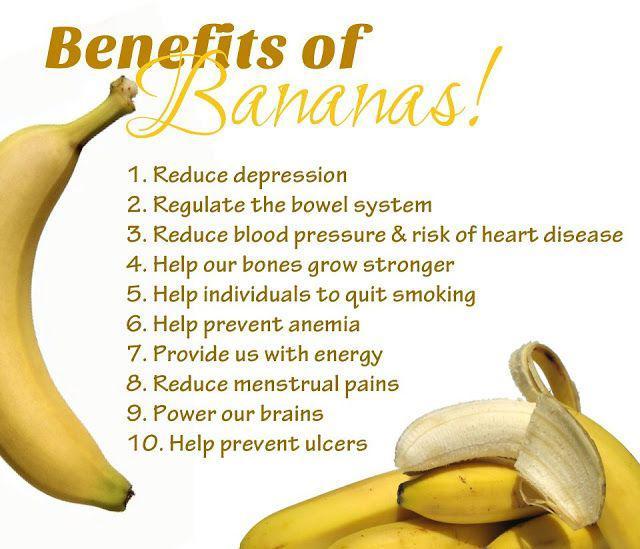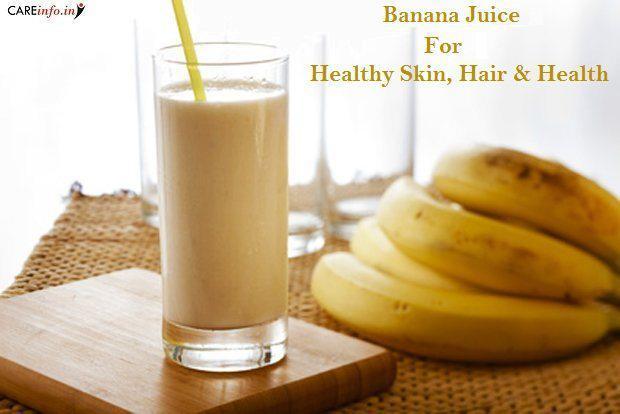The first image is the image on the left, the second image is the image on the right. Assess this claim about the two images: "there is a glass of banana smoothie with a straw and at least 4 whole bananas next to it". Correct or not? Answer yes or no. Yes. The first image is the image on the left, the second image is the image on the right. Considering the images on both sides, is "The glass in the image to the right, it has a straw in it." valid? Answer yes or no. Yes. 